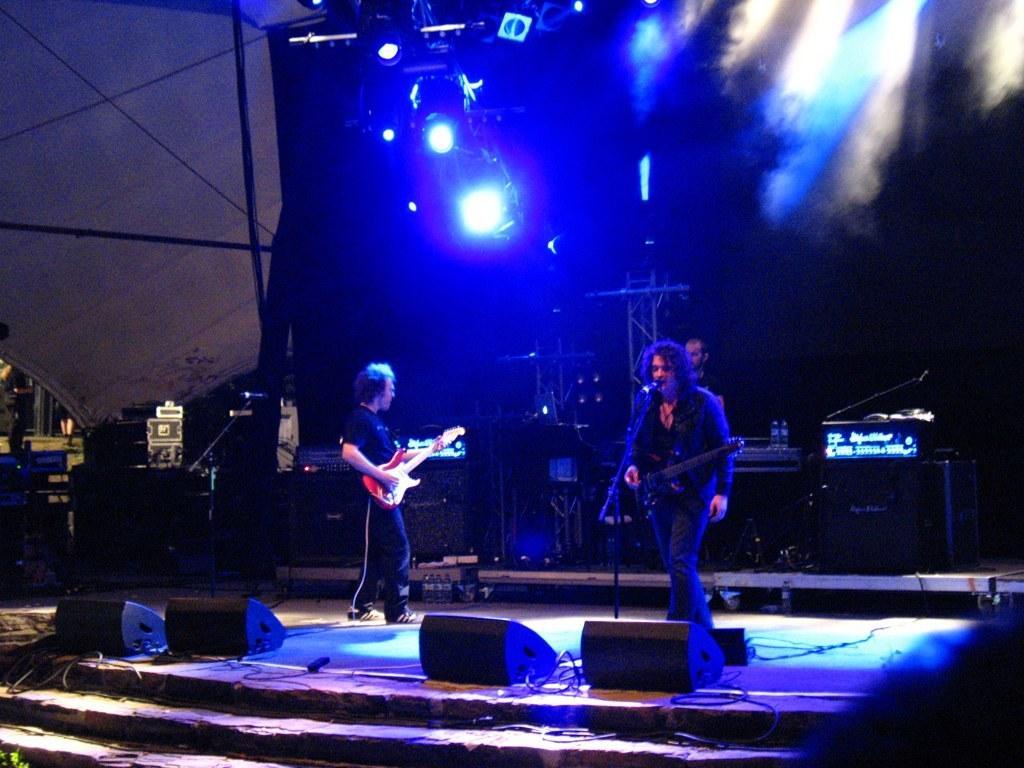Describe this image in one or two sentences. In this picture we can see that a man standing on the stage and singing, and in front there is microphone , and he is holding a guitar in his hand, and at opposite a person is standing and playing the guitar, and at above there are lights, and in front there is stair case. 